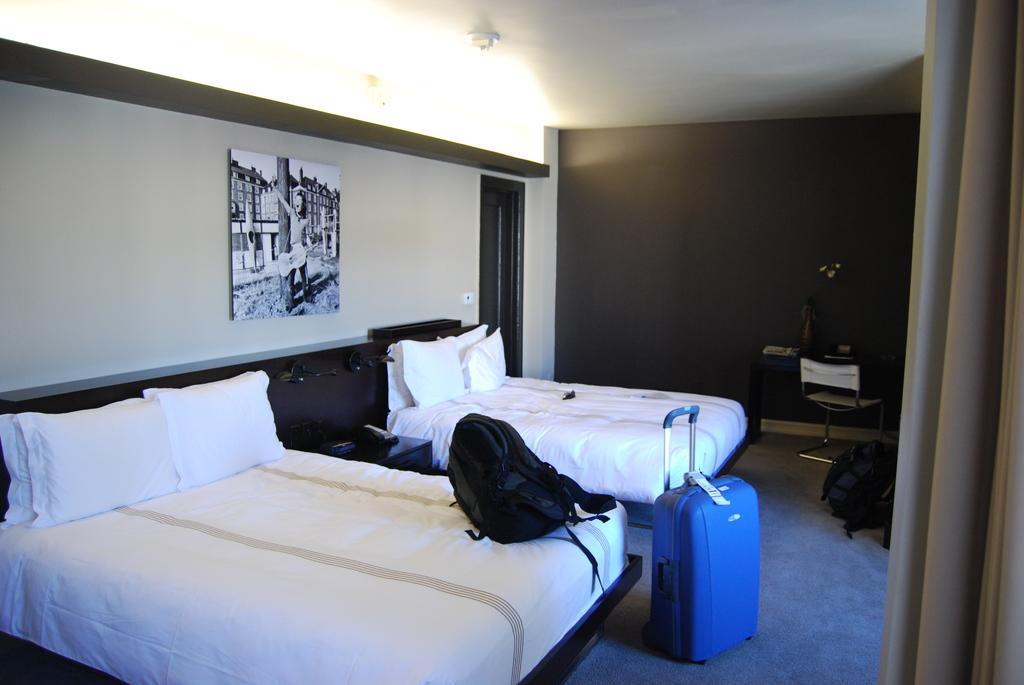Could you give a brief overview of what you see in this image? A picture of a room. There are 2 beds with pillows. This is door. Light with roof top. Picture is attached with wall. On this bed there is a bag. In-front of this bed there is a luggage. This is chair, table. Wall is in black color. 